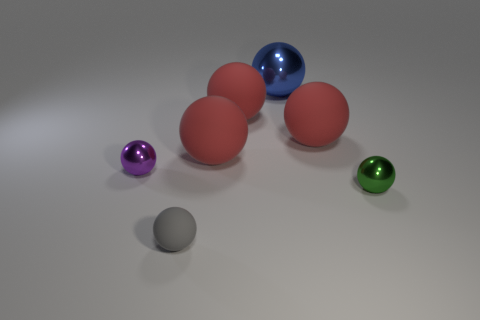Subtract all yellow cylinders. How many red spheres are left? 3 Subtract all green shiny spheres. How many spheres are left? 6 Subtract all gray balls. How many balls are left? 6 Add 1 big metallic objects. How many objects exist? 8 Subtract all brown balls. Subtract all red cylinders. How many balls are left? 7 Subtract all large red matte things. Subtract all green metal spheres. How many objects are left? 3 Add 4 big blue objects. How many big blue objects are left? 5 Add 5 tiny spheres. How many tiny spheres exist? 8 Subtract 0 brown balls. How many objects are left? 7 